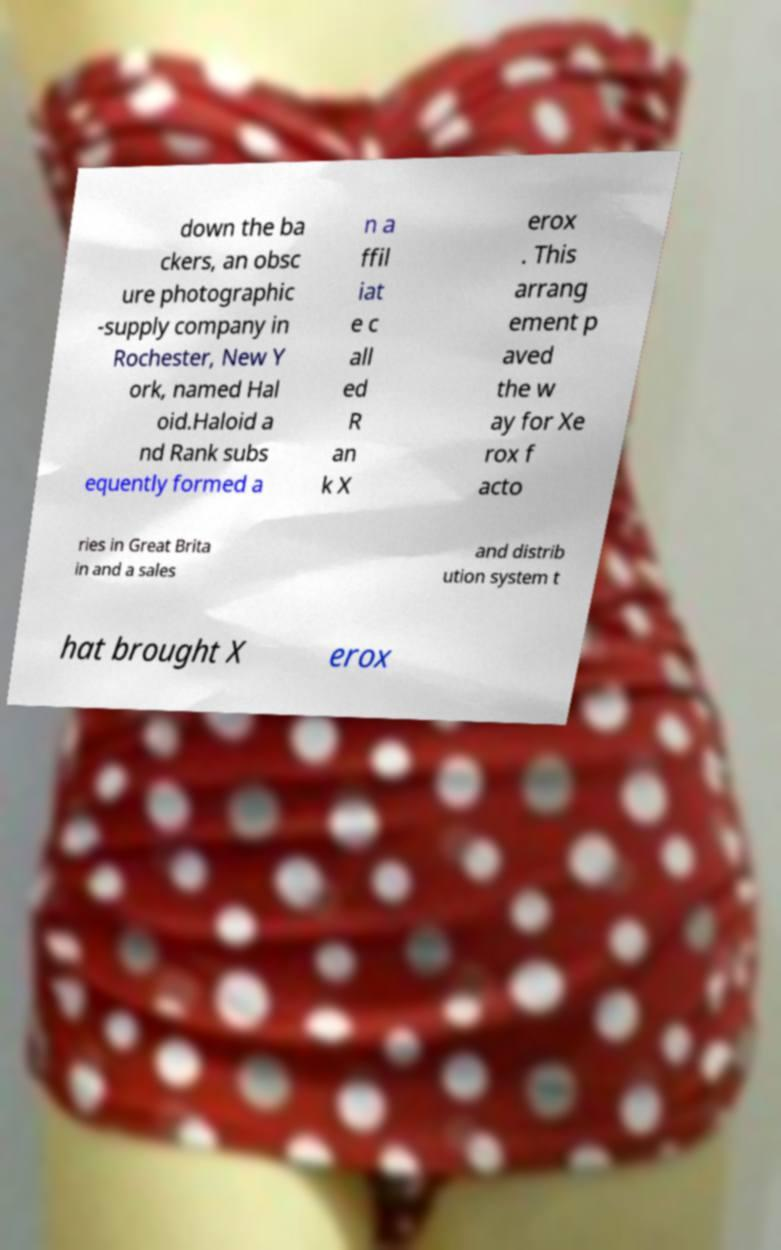Could you extract and type out the text from this image? down the ba ckers, an obsc ure photographic -supply company in Rochester, New Y ork, named Hal oid.Haloid a nd Rank subs equently formed a n a ffil iat e c all ed R an k X erox . This arrang ement p aved the w ay for Xe rox f acto ries in Great Brita in and a sales and distrib ution system t hat brought X erox 